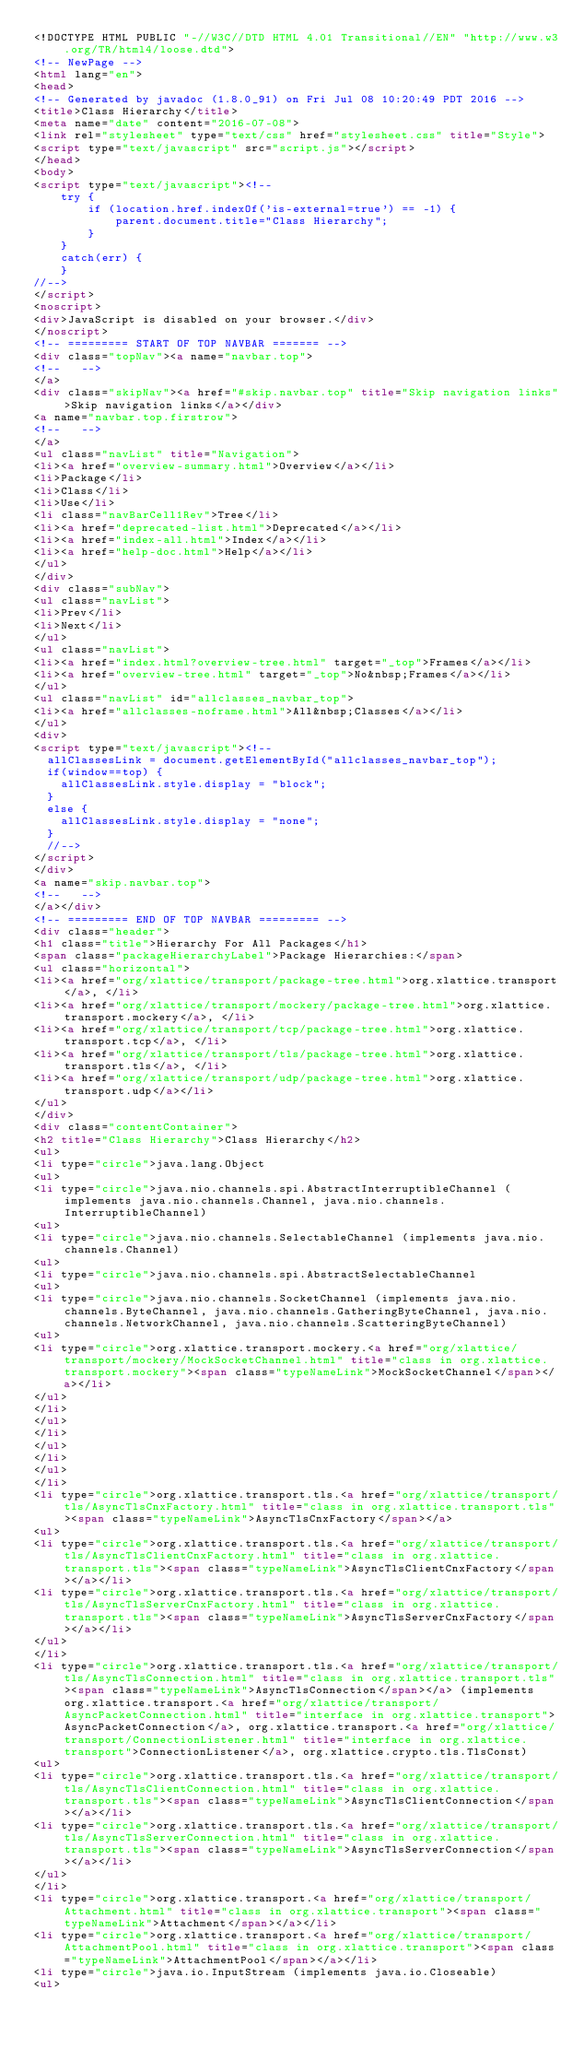<code> <loc_0><loc_0><loc_500><loc_500><_HTML_><!DOCTYPE HTML PUBLIC "-//W3C//DTD HTML 4.01 Transitional//EN" "http://www.w3.org/TR/html4/loose.dtd">
<!-- NewPage -->
<html lang="en">
<head>
<!-- Generated by javadoc (1.8.0_91) on Fri Jul 08 10:20:49 PDT 2016 -->
<title>Class Hierarchy</title>
<meta name="date" content="2016-07-08">
<link rel="stylesheet" type="text/css" href="stylesheet.css" title="Style">
<script type="text/javascript" src="script.js"></script>
</head>
<body>
<script type="text/javascript"><!--
    try {
        if (location.href.indexOf('is-external=true') == -1) {
            parent.document.title="Class Hierarchy";
        }
    }
    catch(err) {
    }
//-->
</script>
<noscript>
<div>JavaScript is disabled on your browser.</div>
</noscript>
<!-- ========= START OF TOP NAVBAR ======= -->
<div class="topNav"><a name="navbar.top">
<!--   -->
</a>
<div class="skipNav"><a href="#skip.navbar.top" title="Skip navigation links">Skip navigation links</a></div>
<a name="navbar.top.firstrow">
<!--   -->
</a>
<ul class="navList" title="Navigation">
<li><a href="overview-summary.html">Overview</a></li>
<li>Package</li>
<li>Class</li>
<li>Use</li>
<li class="navBarCell1Rev">Tree</li>
<li><a href="deprecated-list.html">Deprecated</a></li>
<li><a href="index-all.html">Index</a></li>
<li><a href="help-doc.html">Help</a></li>
</ul>
</div>
<div class="subNav">
<ul class="navList">
<li>Prev</li>
<li>Next</li>
</ul>
<ul class="navList">
<li><a href="index.html?overview-tree.html" target="_top">Frames</a></li>
<li><a href="overview-tree.html" target="_top">No&nbsp;Frames</a></li>
</ul>
<ul class="navList" id="allclasses_navbar_top">
<li><a href="allclasses-noframe.html">All&nbsp;Classes</a></li>
</ul>
<div>
<script type="text/javascript"><!--
  allClassesLink = document.getElementById("allclasses_navbar_top");
  if(window==top) {
    allClassesLink.style.display = "block";
  }
  else {
    allClassesLink.style.display = "none";
  }
  //-->
</script>
</div>
<a name="skip.navbar.top">
<!--   -->
</a></div>
<!-- ========= END OF TOP NAVBAR ========= -->
<div class="header">
<h1 class="title">Hierarchy For All Packages</h1>
<span class="packageHierarchyLabel">Package Hierarchies:</span>
<ul class="horizontal">
<li><a href="org/xlattice/transport/package-tree.html">org.xlattice.transport</a>, </li>
<li><a href="org/xlattice/transport/mockery/package-tree.html">org.xlattice.transport.mockery</a>, </li>
<li><a href="org/xlattice/transport/tcp/package-tree.html">org.xlattice.transport.tcp</a>, </li>
<li><a href="org/xlattice/transport/tls/package-tree.html">org.xlattice.transport.tls</a>, </li>
<li><a href="org/xlattice/transport/udp/package-tree.html">org.xlattice.transport.udp</a></li>
</ul>
</div>
<div class="contentContainer">
<h2 title="Class Hierarchy">Class Hierarchy</h2>
<ul>
<li type="circle">java.lang.Object
<ul>
<li type="circle">java.nio.channels.spi.AbstractInterruptibleChannel (implements java.nio.channels.Channel, java.nio.channels.InterruptibleChannel)
<ul>
<li type="circle">java.nio.channels.SelectableChannel (implements java.nio.channels.Channel)
<ul>
<li type="circle">java.nio.channels.spi.AbstractSelectableChannel
<ul>
<li type="circle">java.nio.channels.SocketChannel (implements java.nio.channels.ByteChannel, java.nio.channels.GatheringByteChannel, java.nio.channels.NetworkChannel, java.nio.channels.ScatteringByteChannel)
<ul>
<li type="circle">org.xlattice.transport.mockery.<a href="org/xlattice/transport/mockery/MockSocketChannel.html" title="class in org.xlattice.transport.mockery"><span class="typeNameLink">MockSocketChannel</span></a></li>
</ul>
</li>
</ul>
</li>
</ul>
</li>
</ul>
</li>
<li type="circle">org.xlattice.transport.tls.<a href="org/xlattice/transport/tls/AsyncTlsCnxFactory.html" title="class in org.xlattice.transport.tls"><span class="typeNameLink">AsyncTlsCnxFactory</span></a>
<ul>
<li type="circle">org.xlattice.transport.tls.<a href="org/xlattice/transport/tls/AsyncTlsClientCnxFactory.html" title="class in org.xlattice.transport.tls"><span class="typeNameLink">AsyncTlsClientCnxFactory</span></a></li>
<li type="circle">org.xlattice.transport.tls.<a href="org/xlattice/transport/tls/AsyncTlsServerCnxFactory.html" title="class in org.xlattice.transport.tls"><span class="typeNameLink">AsyncTlsServerCnxFactory</span></a></li>
</ul>
</li>
<li type="circle">org.xlattice.transport.tls.<a href="org/xlattice/transport/tls/AsyncTlsConnection.html" title="class in org.xlattice.transport.tls"><span class="typeNameLink">AsyncTlsConnection</span></a> (implements org.xlattice.transport.<a href="org/xlattice/transport/AsyncPacketConnection.html" title="interface in org.xlattice.transport">AsyncPacketConnection</a>, org.xlattice.transport.<a href="org/xlattice/transport/ConnectionListener.html" title="interface in org.xlattice.transport">ConnectionListener</a>, org.xlattice.crypto.tls.TlsConst)
<ul>
<li type="circle">org.xlattice.transport.tls.<a href="org/xlattice/transport/tls/AsyncTlsClientConnection.html" title="class in org.xlattice.transport.tls"><span class="typeNameLink">AsyncTlsClientConnection</span></a></li>
<li type="circle">org.xlattice.transport.tls.<a href="org/xlattice/transport/tls/AsyncTlsServerConnection.html" title="class in org.xlattice.transport.tls"><span class="typeNameLink">AsyncTlsServerConnection</span></a></li>
</ul>
</li>
<li type="circle">org.xlattice.transport.<a href="org/xlattice/transport/Attachment.html" title="class in org.xlattice.transport"><span class="typeNameLink">Attachment</span></a></li>
<li type="circle">org.xlattice.transport.<a href="org/xlattice/transport/AttachmentPool.html" title="class in org.xlattice.transport"><span class="typeNameLink">AttachmentPool</span></a></li>
<li type="circle">java.io.InputStream (implements java.io.Closeable)
<ul></code> 